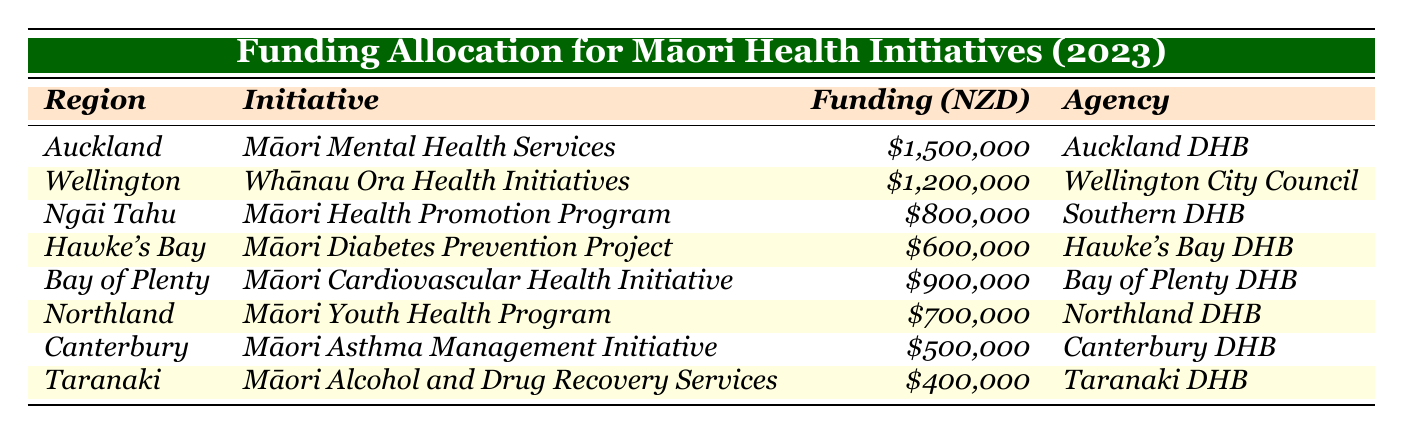What is the highest funding amount allocated for a health initiative? The highest funding amount is found in the row for Auckland, which indicates a funding allocation of NZD 1,500,000 for the Māori Mental Health Services initiative.
Answer: NZD 1,500,000 Which region received the lowest funding allocation? Review the last row in the table to find Taranaki, which received NZD 400,000 for the Māori Alcohol and Drug Recovery Services initiative, the smallest amount.
Answer: NZD 400,000 How many different agencies are involved in funding the health initiatives? Identify the unique agencies listed in the table. There are eight agencies, each associated with a different initiative, detailing their unique involvement.
Answer: 8 What is the total amount of funding allocated across all regions? Sum all the funding amounts from each row: 1,500,000 + 1,200,000 + 800,000 + 600,000 + 900,000 + 700,000 + 500,000 + 400,000 = 6,600,000.
Answer: NZD 6,600,000 Is the funding allocation for Māori Diabetes Prevention Project greater than that for Māori Youth Health Program? Compare the funding amounts: Māori Diabetes Prevention Project (Hawke's Bay) received NZD 600,000, and Māori Youth Health Program (Northland) received NZD 700,000. Since 600,000 < 700,000, the statement is false.
Answer: No How much more funding did the Auckland District Health Board receive compared to the Canterbury District Health Board? The Auckland District Health Board received NZD 1,500,000 and the Canterbury District Health Board received NZD 500,000. The difference is 1,500,000 - 500,000 = 1,000,000.
Answer: NZD 1,000,000 What percentage of the total funding was allocated to the Whānau Ora Health Initiatives in Wellington? First, find the total funding amount of NZD 6,600,000. Next, calculate the percentage for Whānau Ora Health Initiatives (NZD 1,200,000): (1,200,000 / 6,600,000) * 100 = 18.18%.
Answer: 18.18% Which initiative has the funding amount closest to NZD 700,000? Look through the funding amounts: both the Northland Māori Youth Health Program (NZD 700,000) and the Māori Health Promotion Program (Ngāi Tahu) at NZD 800,000 are close, but Māori Youth Health Program is equal.
Answer: Māori Youth Health Program What can you infer about the focus areas of health initiatives based on the funding allocation? By analyzing the initiatives and their associated funding, it seems there is a varied focus, with mental health and wellness receiving significant funds, indicating a priority for these areas in Māori health initiatives.
Answer: Varied focus, emphasis on mental health 